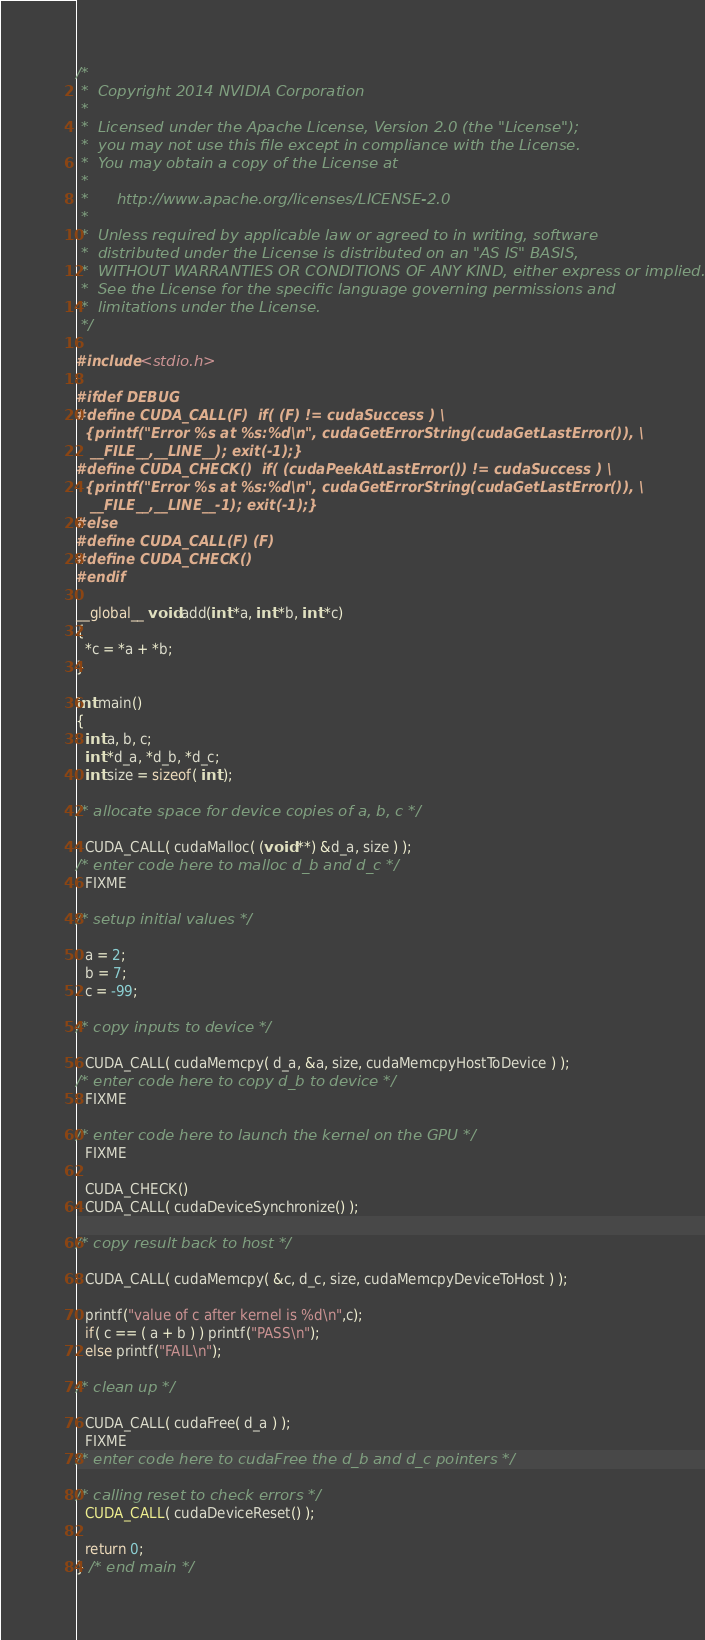Convert code to text. <code><loc_0><loc_0><loc_500><loc_500><_Cuda_>/*
 *  Copyright 2014 NVIDIA Corporation
 *
 *  Licensed under the Apache License, Version 2.0 (the "License");
 *  you may not use this file except in compliance with the License.
 *  You may obtain a copy of the License at
 *
 *      http://www.apache.org/licenses/LICENSE-2.0
 *
 *  Unless required by applicable law or agreed to in writing, software
 *  distributed under the License is distributed on an "AS IS" BASIS,
 *  WITHOUT WARRANTIES OR CONDITIONS OF ANY KIND, either express or implied.
 *  See the License for the specific language governing permissions and
 *  limitations under the License.
 */

#include <stdio.h>

#ifdef DEBUG
#define CUDA_CALL(F)  if( (F) != cudaSuccess ) \
  {printf("Error %s at %s:%d\n", cudaGetErrorString(cudaGetLastError()), \
   __FILE__,__LINE__); exit(-1);} 
#define CUDA_CHECK()  if( (cudaPeekAtLastError()) != cudaSuccess ) \
  {printf("Error %s at %s:%d\n", cudaGetErrorString(cudaGetLastError()), \
   __FILE__,__LINE__-1); exit(-1);} 
#else
#define CUDA_CALL(F) (F)
#define CUDA_CHECK() 
#endif

__global__ void add(int *a, int *b, int *c)
{
  *c = *a + *b;
}

int main()
{
  int a, b, c;
  int *d_a, *d_b, *d_c;
  int size = sizeof( int );

/* allocate space for device copies of a, b, c */

  CUDA_CALL( cudaMalloc( (void **) &d_a, size ) );
/* enter code here to malloc d_b and d_c */
  FIXME

/* setup initial values */

  a = 2;
  b = 7;
  c = -99;

/* copy inputs to device */

  CUDA_CALL( cudaMemcpy( d_a, &a, size, cudaMemcpyHostToDevice ) );
/* enter code here to copy d_b to device */
  FIXME

/* enter code here to launch the kernel on the GPU */
  FIXME

  CUDA_CHECK()
  CUDA_CALL( cudaDeviceSynchronize() );

/* copy result back to host */

  CUDA_CALL( cudaMemcpy( &c, d_c, size, cudaMemcpyDeviceToHost ) );

  printf("value of c after kernel is %d\n",c);
  if( c == ( a + b ) ) printf("PASS\n");
  else printf("FAIL\n");

/* clean up */

  CUDA_CALL( cudaFree( d_a ) );
  FIXME
/* enter code here to cudaFree the d_b and d_c pointers */

/* calling reset to check errors */
  CUDA_CALL( cudaDeviceReset() );
	
  return 0;
} /* end main */
</code> 